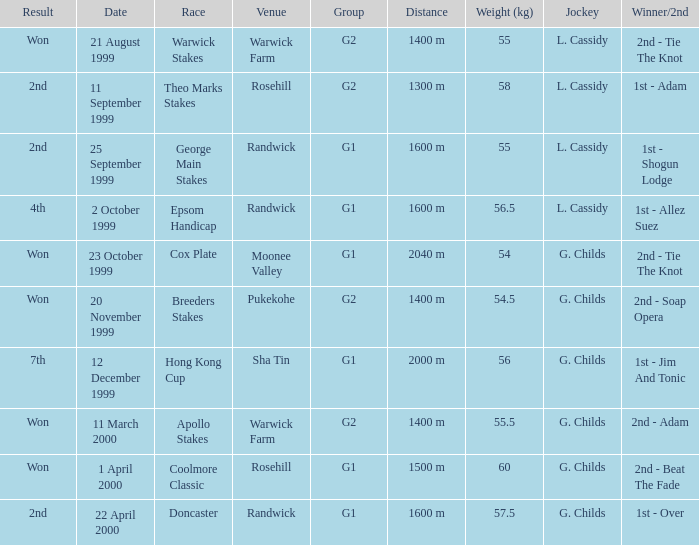How man teams had a total weight of 57.5? 1.0. 